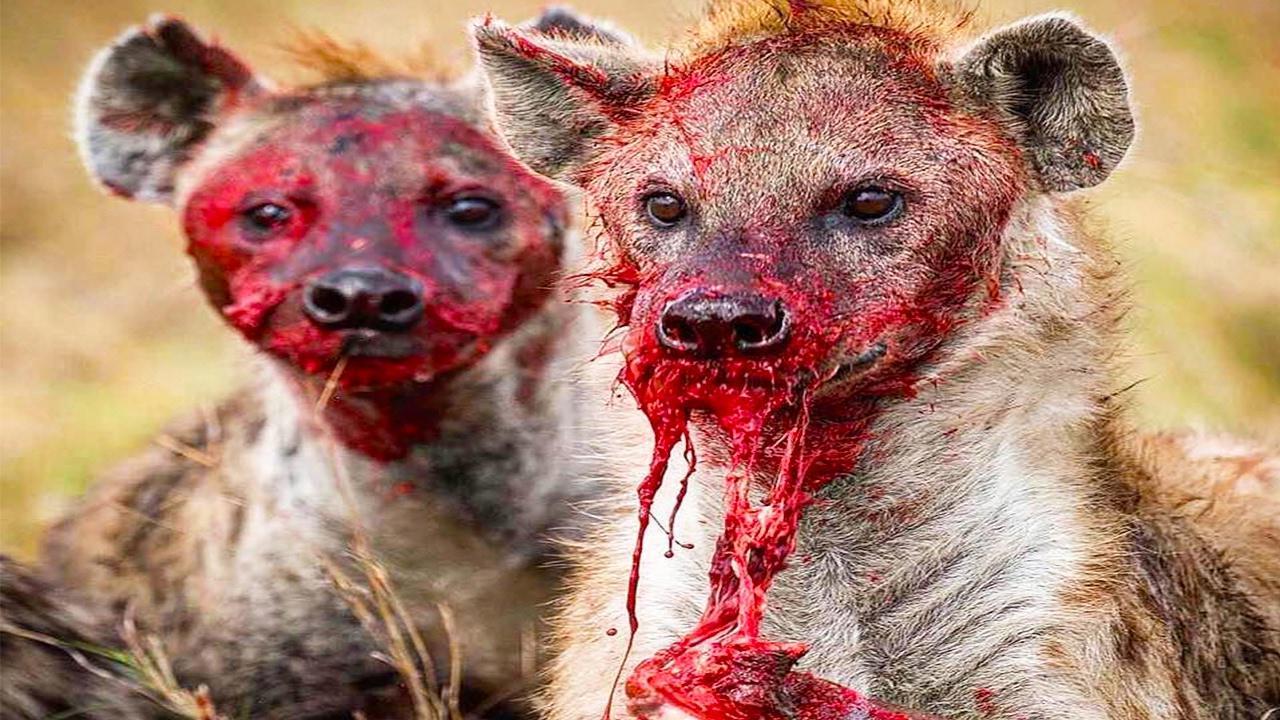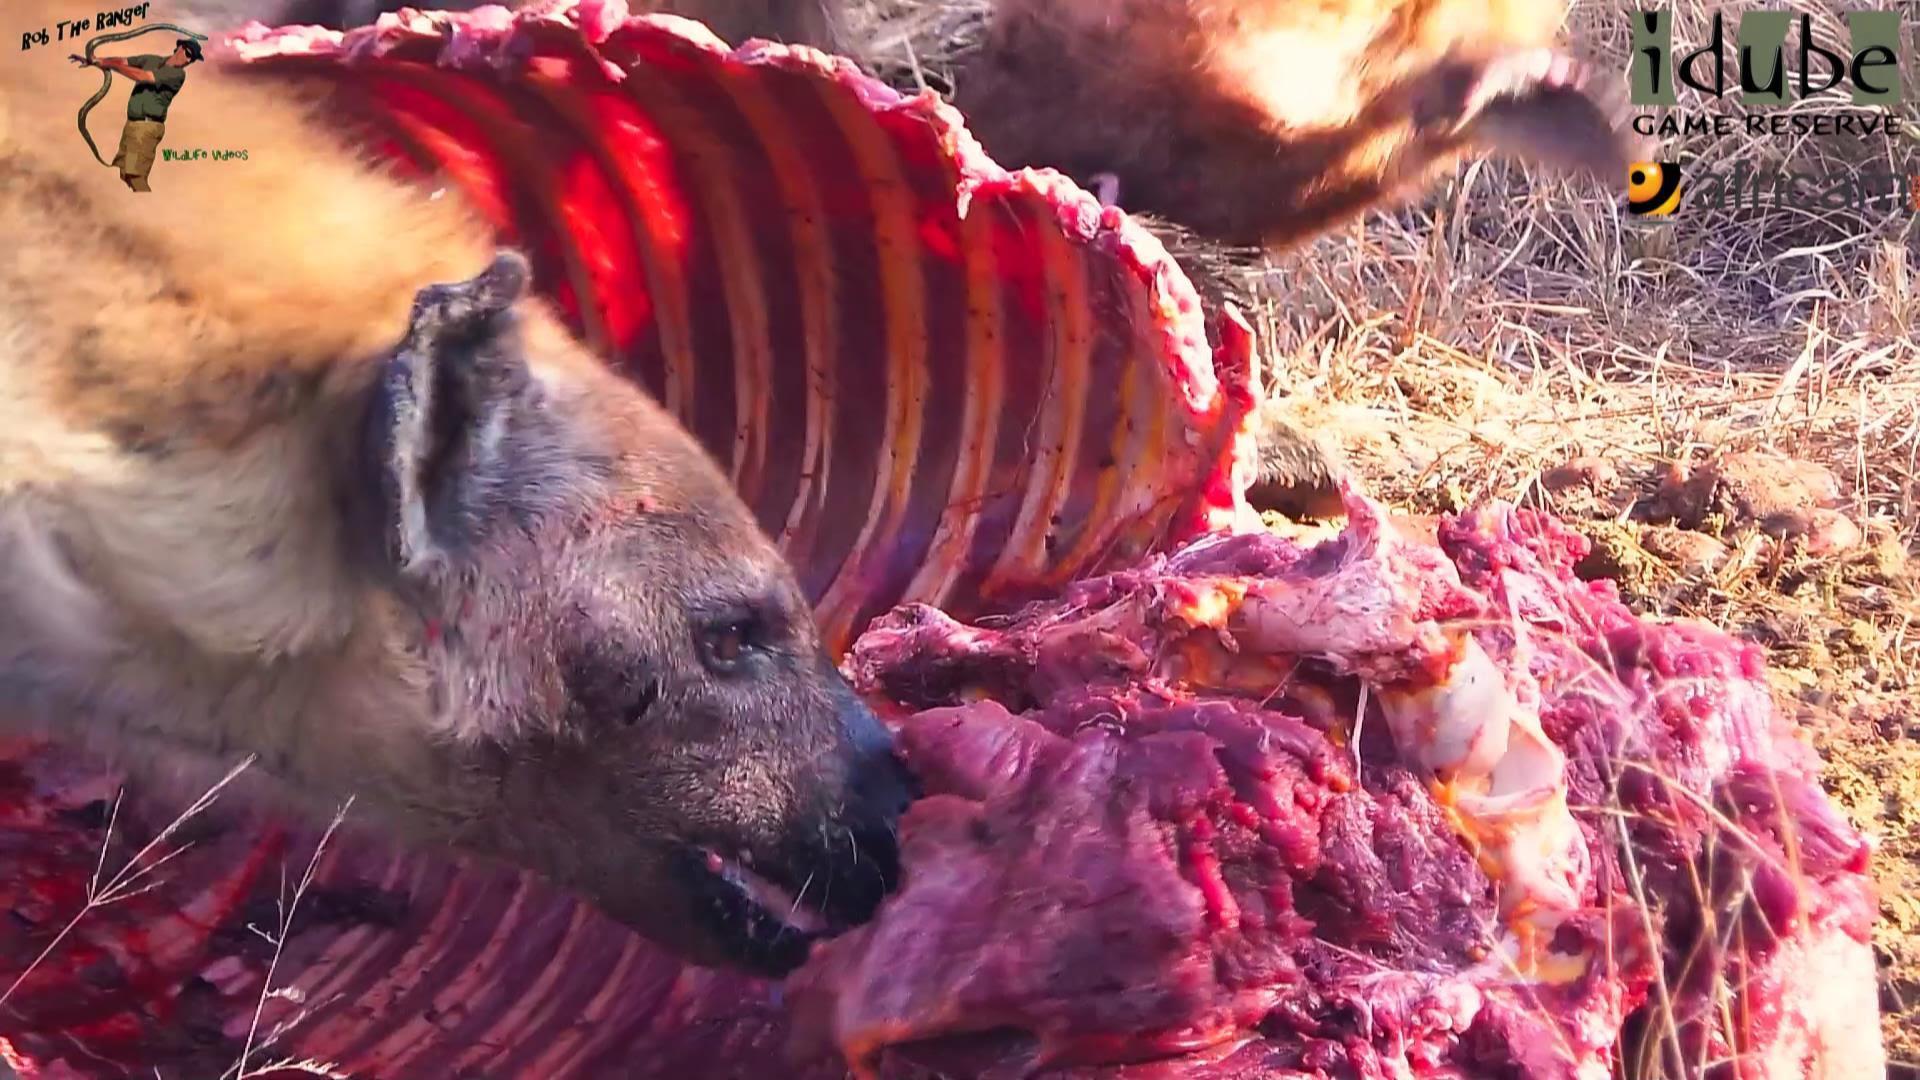The first image is the image on the left, the second image is the image on the right. Given the left and right images, does the statement "The left image contains one hyena with its teeth exposed and their tongue hanging out." hold true? Answer yes or no. No. The first image is the image on the left, the second image is the image on the right. For the images shown, is this caption "The right image shows at least one hyena grasping at a zebra carcass with its black and white striped hide still partly intact." true? Answer yes or no. No. 